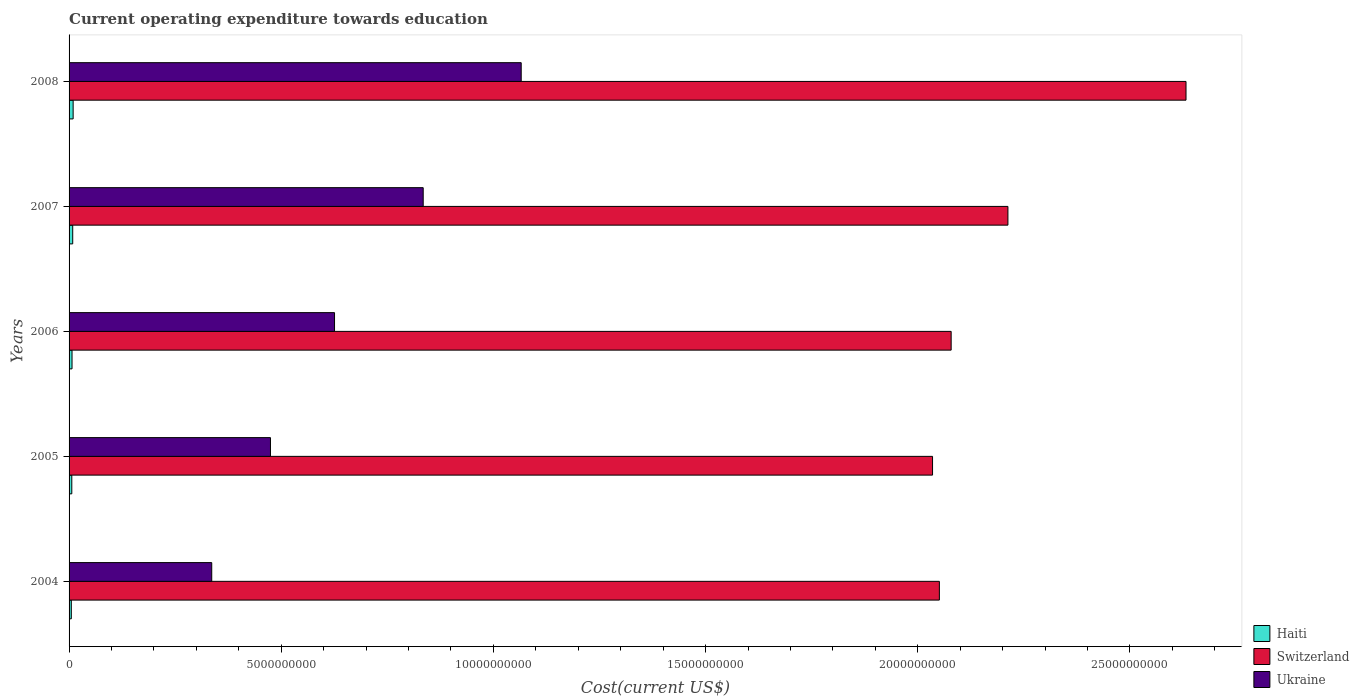How many different coloured bars are there?
Give a very brief answer. 3. How many groups of bars are there?
Ensure brevity in your answer.  5. Are the number of bars per tick equal to the number of legend labels?
Offer a terse response. Yes. How many bars are there on the 3rd tick from the top?
Your answer should be compact. 3. What is the label of the 4th group of bars from the top?
Offer a very short reply. 2005. In how many cases, is the number of bars for a given year not equal to the number of legend labels?
Offer a very short reply. 0. What is the expenditure towards education in Haiti in 2006?
Provide a succinct answer. 6.96e+07. Across all years, what is the maximum expenditure towards education in Ukraine?
Provide a short and direct response. 1.07e+1. Across all years, what is the minimum expenditure towards education in Switzerland?
Make the answer very short. 2.03e+1. In which year was the expenditure towards education in Ukraine maximum?
Your response must be concise. 2008. What is the total expenditure towards education in Ukraine in the graph?
Provide a succinct answer. 3.34e+1. What is the difference between the expenditure towards education in Haiti in 2004 and that in 2007?
Provide a succinct answer. -3.33e+07. What is the difference between the expenditure towards education in Switzerland in 2006 and the expenditure towards education in Haiti in 2008?
Your answer should be compact. 2.07e+1. What is the average expenditure towards education in Ukraine per year?
Provide a short and direct response. 6.67e+09. In the year 2006, what is the difference between the expenditure towards education in Switzerland and expenditure towards education in Ukraine?
Provide a succinct answer. 1.45e+1. What is the ratio of the expenditure towards education in Switzerland in 2005 to that in 2008?
Your answer should be very brief. 0.77. Is the expenditure towards education in Haiti in 2005 less than that in 2006?
Give a very brief answer. Yes. Is the difference between the expenditure towards education in Switzerland in 2006 and 2007 greater than the difference between the expenditure towards education in Ukraine in 2006 and 2007?
Your answer should be compact. Yes. What is the difference between the highest and the second highest expenditure towards education in Switzerland?
Ensure brevity in your answer.  4.20e+09. What is the difference between the highest and the lowest expenditure towards education in Ukraine?
Offer a very short reply. 7.29e+09. Is the sum of the expenditure towards education in Switzerland in 2005 and 2008 greater than the maximum expenditure towards education in Ukraine across all years?
Ensure brevity in your answer.  Yes. What does the 1st bar from the top in 2006 represents?
Provide a short and direct response. Ukraine. What does the 2nd bar from the bottom in 2005 represents?
Your answer should be very brief. Switzerland. How many bars are there?
Provide a short and direct response. 15. How many years are there in the graph?
Your response must be concise. 5. Are the values on the major ticks of X-axis written in scientific E-notation?
Give a very brief answer. No. Does the graph contain any zero values?
Your answer should be compact. No. Does the graph contain grids?
Provide a succinct answer. No. What is the title of the graph?
Ensure brevity in your answer.  Current operating expenditure towards education. What is the label or title of the X-axis?
Offer a very short reply. Cost(current US$). What is the label or title of the Y-axis?
Your response must be concise. Years. What is the Cost(current US$) of Haiti in 2004?
Ensure brevity in your answer.  5.28e+07. What is the Cost(current US$) in Switzerland in 2004?
Offer a terse response. 2.05e+1. What is the Cost(current US$) of Ukraine in 2004?
Your answer should be compact. 3.36e+09. What is the Cost(current US$) in Haiti in 2005?
Keep it short and to the point. 6.41e+07. What is the Cost(current US$) of Switzerland in 2005?
Keep it short and to the point. 2.03e+1. What is the Cost(current US$) in Ukraine in 2005?
Your answer should be very brief. 4.75e+09. What is the Cost(current US$) in Haiti in 2006?
Provide a succinct answer. 6.96e+07. What is the Cost(current US$) of Switzerland in 2006?
Provide a succinct answer. 2.08e+1. What is the Cost(current US$) of Ukraine in 2006?
Your answer should be compact. 6.26e+09. What is the Cost(current US$) of Haiti in 2007?
Offer a very short reply. 8.61e+07. What is the Cost(current US$) in Switzerland in 2007?
Offer a very short reply. 2.21e+1. What is the Cost(current US$) of Ukraine in 2007?
Provide a short and direct response. 8.35e+09. What is the Cost(current US$) of Haiti in 2008?
Your answer should be very brief. 9.58e+07. What is the Cost(current US$) of Switzerland in 2008?
Offer a terse response. 2.63e+1. What is the Cost(current US$) of Ukraine in 2008?
Offer a very short reply. 1.07e+1. Across all years, what is the maximum Cost(current US$) in Haiti?
Keep it short and to the point. 9.58e+07. Across all years, what is the maximum Cost(current US$) in Switzerland?
Your answer should be very brief. 2.63e+1. Across all years, what is the maximum Cost(current US$) in Ukraine?
Make the answer very short. 1.07e+1. Across all years, what is the minimum Cost(current US$) in Haiti?
Keep it short and to the point. 5.28e+07. Across all years, what is the minimum Cost(current US$) of Switzerland?
Provide a short and direct response. 2.03e+1. Across all years, what is the minimum Cost(current US$) of Ukraine?
Make the answer very short. 3.36e+09. What is the total Cost(current US$) in Haiti in the graph?
Ensure brevity in your answer.  3.68e+08. What is the total Cost(current US$) in Switzerland in the graph?
Offer a very short reply. 1.10e+11. What is the total Cost(current US$) in Ukraine in the graph?
Ensure brevity in your answer.  3.34e+1. What is the difference between the Cost(current US$) in Haiti in 2004 and that in 2005?
Ensure brevity in your answer.  -1.13e+07. What is the difference between the Cost(current US$) in Switzerland in 2004 and that in 2005?
Give a very brief answer. 1.61e+08. What is the difference between the Cost(current US$) of Ukraine in 2004 and that in 2005?
Provide a short and direct response. -1.38e+09. What is the difference between the Cost(current US$) of Haiti in 2004 and that in 2006?
Give a very brief answer. -1.68e+07. What is the difference between the Cost(current US$) of Switzerland in 2004 and that in 2006?
Offer a very short reply. -2.77e+08. What is the difference between the Cost(current US$) in Ukraine in 2004 and that in 2006?
Your answer should be compact. -2.89e+09. What is the difference between the Cost(current US$) of Haiti in 2004 and that in 2007?
Give a very brief answer. -3.33e+07. What is the difference between the Cost(current US$) in Switzerland in 2004 and that in 2007?
Your response must be concise. -1.62e+09. What is the difference between the Cost(current US$) in Ukraine in 2004 and that in 2007?
Offer a very short reply. -4.98e+09. What is the difference between the Cost(current US$) in Haiti in 2004 and that in 2008?
Provide a short and direct response. -4.30e+07. What is the difference between the Cost(current US$) of Switzerland in 2004 and that in 2008?
Provide a succinct answer. -5.81e+09. What is the difference between the Cost(current US$) of Ukraine in 2004 and that in 2008?
Provide a short and direct response. -7.29e+09. What is the difference between the Cost(current US$) of Haiti in 2005 and that in 2006?
Your answer should be very brief. -5.51e+06. What is the difference between the Cost(current US$) in Switzerland in 2005 and that in 2006?
Provide a short and direct response. -4.38e+08. What is the difference between the Cost(current US$) of Ukraine in 2005 and that in 2006?
Make the answer very short. -1.51e+09. What is the difference between the Cost(current US$) of Haiti in 2005 and that in 2007?
Make the answer very short. -2.19e+07. What is the difference between the Cost(current US$) in Switzerland in 2005 and that in 2007?
Provide a short and direct response. -1.78e+09. What is the difference between the Cost(current US$) in Ukraine in 2005 and that in 2007?
Offer a very short reply. -3.60e+09. What is the difference between the Cost(current US$) in Haiti in 2005 and that in 2008?
Provide a succinct answer. -3.17e+07. What is the difference between the Cost(current US$) of Switzerland in 2005 and that in 2008?
Provide a succinct answer. -5.97e+09. What is the difference between the Cost(current US$) in Ukraine in 2005 and that in 2008?
Give a very brief answer. -5.91e+09. What is the difference between the Cost(current US$) of Haiti in 2006 and that in 2007?
Offer a very short reply. -1.64e+07. What is the difference between the Cost(current US$) in Switzerland in 2006 and that in 2007?
Your response must be concise. -1.34e+09. What is the difference between the Cost(current US$) of Ukraine in 2006 and that in 2007?
Provide a succinct answer. -2.09e+09. What is the difference between the Cost(current US$) of Haiti in 2006 and that in 2008?
Provide a short and direct response. -2.62e+07. What is the difference between the Cost(current US$) of Switzerland in 2006 and that in 2008?
Keep it short and to the point. -5.53e+09. What is the difference between the Cost(current US$) of Ukraine in 2006 and that in 2008?
Give a very brief answer. -4.40e+09. What is the difference between the Cost(current US$) in Haiti in 2007 and that in 2008?
Provide a short and direct response. -9.74e+06. What is the difference between the Cost(current US$) in Switzerland in 2007 and that in 2008?
Keep it short and to the point. -4.20e+09. What is the difference between the Cost(current US$) of Ukraine in 2007 and that in 2008?
Give a very brief answer. -2.31e+09. What is the difference between the Cost(current US$) of Haiti in 2004 and the Cost(current US$) of Switzerland in 2005?
Your answer should be compact. -2.03e+1. What is the difference between the Cost(current US$) in Haiti in 2004 and the Cost(current US$) in Ukraine in 2005?
Offer a very short reply. -4.69e+09. What is the difference between the Cost(current US$) in Switzerland in 2004 and the Cost(current US$) in Ukraine in 2005?
Offer a terse response. 1.58e+1. What is the difference between the Cost(current US$) in Haiti in 2004 and the Cost(current US$) in Switzerland in 2006?
Make the answer very short. -2.07e+1. What is the difference between the Cost(current US$) in Haiti in 2004 and the Cost(current US$) in Ukraine in 2006?
Ensure brevity in your answer.  -6.20e+09. What is the difference between the Cost(current US$) of Switzerland in 2004 and the Cost(current US$) of Ukraine in 2006?
Keep it short and to the point. 1.43e+1. What is the difference between the Cost(current US$) in Haiti in 2004 and the Cost(current US$) in Switzerland in 2007?
Ensure brevity in your answer.  -2.21e+1. What is the difference between the Cost(current US$) in Haiti in 2004 and the Cost(current US$) in Ukraine in 2007?
Your answer should be very brief. -8.29e+09. What is the difference between the Cost(current US$) of Switzerland in 2004 and the Cost(current US$) of Ukraine in 2007?
Keep it short and to the point. 1.22e+1. What is the difference between the Cost(current US$) in Haiti in 2004 and the Cost(current US$) in Switzerland in 2008?
Offer a very short reply. -2.63e+1. What is the difference between the Cost(current US$) of Haiti in 2004 and the Cost(current US$) of Ukraine in 2008?
Ensure brevity in your answer.  -1.06e+1. What is the difference between the Cost(current US$) in Switzerland in 2004 and the Cost(current US$) in Ukraine in 2008?
Provide a succinct answer. 9.85e+09. What is the difference between the Cost(current US$) in Haiti in 2005 and the Cost(current US$) in Switzerland in 2006?
Offer a terse response. -2.07e+1. What is the difference between the Cost(current US$) of Haiti in 2005 and the Cost(current US$) of Ukraine in 2006?
Provide a succinct answer. -6.19e+09. What is the difference between the Cost(current US$) of Switzerland in 2005 and the Cost(current US$) of Ukraine in 2006?
Offer a terse response. 1.41e+1. What is the difference between the Cost(current US$) in Haiti in 2005 and the Cost(current US$) in Switzerland in 2007?
Your response must be concise. -2.21e+1. What is the difference between the Cost(current US$) in Haiti in 2005 and the Cost(current US$) in Ukraine in 2007?
Offer a terse response. -8.28e+09. What is the difference between the Cost(current US$) of Switzerland in 2005 and the Cost(current US$) of Ukraine in 2007?
Offer a very short reply. 1.20e+1. What is the difference between the Cost(current US$) in Haiti in 2005 and the Cost(current US$) in Switzerland in 2008?
Offer a very short reply. -2.63e+1. What is the difference between the Cost(current US$) in Haiti in 2005 and the Cost(current US$) in Ukraine in 2008?
Provide a short and direct response. -1.06e+1. What is the difference between the Cost(current US$) of Switzerland in 2005 and the Cost(current US$) of Ukraine in 2008?
Your response must be concise. 9.69e+09. What is the difference between the Cost(current US$) of Haiti in 2006 and the Cost(current US$) of Switzerland in 2007?
Make the answer very short. -2.21e+1. What is the difference between the Cost(current US$) of Haiti in 2006 and the Cost(current US$) of Ukraine in 2007?
Your answer should be very brief. -8.28e+09. What is the difference between the Cost(current US$) of Switzerland in 2006 and the Cost(current US$) of Ukraine in 2007?
Your answer should be compact. 1.24e+1. What is the difference between the Cost(current US$) in Haiti in 2006 and the Cost(current US$) in Switzerland in 2008?
Ensure brevity in your answer.  -2.63e+1. What is the difference between the Cost(current US$) of Haiti in 2006 and the Cost(current US$) of Ukraine in 2008?
Provide a succinct answer. -1.06e+1. What is the difference between the Cost(current US$) of Switzerland in 2006 and the Cost(current US$) of Ukraine in 2008?
Give a very brief answer. 1.01e+1. What is the difference between the Cost(current US$) of Haiti in 2007 and the Cost(current US$) of Switzerland in 2008?
Your answer should be very brief. -2.62e+1. What is the difference between the Cost(current US$) of Haiti in 2007 and the Cost(current US$) of Ukraine in 2008?
Keep it short and to the point. -1.06e+1. What is the difference between the Cost(current US$) of Switzerland in 2007 and the Cost(current US$) of Ukraine in 2008?
Offer a terse response. 1.15e+1. What is the average Cost(current US$) of Haiti per year?
Your answer should be very brief. 7.37e+07. What is the average Cost(current US$) of Switzerland per year?
Offer a terse response. 2.20e+1. What is the average Cost(current US$) of Ukraine per year?
Offer a very short reply. 6.67e+09. In the year 2004, what is the difference between the Cost(current US$) of Haiti and Cost(current US$) of Switzerland?
Make the answer very short. -2.05e+1. In the year 2004, what is the difference between the Cost(current US$) of Haiti and Cost(current US$) of Ukraine?
Your answer should be very brief. -3.31e+09. In the year 2004, what is the difference between the Cost(current US$) in Switzerland and Cost(current US$) in Ukraine?
Your answer should be very brief. 1.71e+1. In the year 2005, what is the difference between the Cost(current US$) of Haiti and Cost(current US$) of Switzerland?
Offer a terse response. -2.03e+1. In the year 2005, what is the difference between the Cost(current US$) in Haiti and Cost(current US$) in Ukraine?
Your response must be concise. -4.68e+09. In the year 2005, what is the difference between the Cost(current US$) of Switzerland and Cost(current US$) of Ukraine?
Your response must be concise. 1.56e+1. In the year 2006, what is the difference between the Cost(current US$) of Haiti and Cost(current US$) of Switzerland?
Offer a very short reply. -2.07e+1. In the year 2006, what is the difference between the Cost(current US$) in Haiti and Cost(current US$) in Ukraine?
Ensure brevity in your answer.  -6.19e+09. In the year 2006, what is the difference between the Cost(current US$) of Switzerland and Cost(current US$) of Ukraine?
Your response must be concise. 1.45e+1. In the year 2007, what is the difference between the Cost(current US$) of Haiti and Cost(current US$) of Switzerland?
Provide a short and direct response. -2.20e+1. In the year 2007, what is the difference between the Cost(current US$) of Haiti and Cost(current US$) of Ukraine?
Give a very brief answer. -8.26e+09. In the year 2007, what is the difference between the Cost(current US$) of Switzerland and Cost(current US$) of Ukraine?
Provide a short and direct response. 1.38e+1. In the year 2008, what is the difference between the Cost(current US$) in Haiti and Cost(current US$) in Switzerland?
Offer a very short reply. -2.62e+1. In the year 2008, what is the difference between the Cost(current US$) in Haiti and Cost(current US$) in Ukraine?
Your answer should be compact. -1.06e+1. In the year 2008, what is the difference between the Cost(current US$) in Switzerland and Cost(current US$) in Ukraine?
Offer a very short reply. 1.57e+1. What is the ratio of the Cost(current US$) in Haiti in 2004 to that in 2005?
Your response must be concise. 0.82. What is the ratio of the Cost(current US$) of Switzerland in 2004 to that in 2005?
Your answer should be compact. 1.01. What is the ratio of the Cost(current US$) of Ukraine in 2004 to that in 2005?
Offer a terse response. 0.71. What is the ratio of the Cost(current US$) of Haiti in 2004 to that in 2006?
Give a very brief answer. 0.76. What is the ratio of the Cost(current US$) in Switzerland in 2004 to that in 2006?
Provide a short and direct response. 0.99. What is the ratio of the Cost(current US$) in Ukraine in 2004 to that in 2006?
Provide a succinct answer. 0.54. What is the ratio of the Cost(current US$) of Haiti in 2004 to that in 2007?
Provide a succinct answer. 0.61. What is the ratio of the Cost(current US$) of Switzerland in 2004 to that in 2007?
Your response must be concise. 0.93. What is the ratio of the Cost(current US$) of Ukraine in 2004 to that in 2007?
Provide a succinct answer. 0.4. What is the ratio of the Cost(current US$) of Haiti in 2004 to that in 2008?
Provide a short and direct response. 0.55. What is the ratio of the Cost(current US$) of Switzerland in 2004 to that in 2008?
Offer a terse response. 0.78. What is the ratio of the Cost(current US$) in Ukraine in 2004 to that in 2008?
Give a very brief answer. 0.32. What is the ratio of the Cost(current US$) of Haiti in 2005 to that in 2006?
Provide a short and direct response. 0.92. What is the ratio of the Cost(current US$) of Switzerland in 2005 to that in 2006?
Give a very brief answer. 0.98. What is the ratio of the Cost(current US$) of Ukraine in 2005 to that in 2006?
Keep it short and to the point. 0.76. What is the ratio of the Cost(current US$) of Haiti in 2005 to that in 2007?
Your answer should be very brief. 0.75. What is the ratio of the Cost(current US$) in Switzerland in 2005 to that in 2007?
Offer a terse response. 0.92. What is the ratio of the Cost(current US$) of Ukraine in 2005 to that in 2007?
Provide a succinct answer. 0.57. What is the ratio of the Cost(current US$) in Haiti in 2005 to that in 2008?
Give a very brief answer. 0.67. What is the ratio of the Cost(current US$) in Switzerland in 2005 to that in 2008?
Provide a short and direct response. 0.77. What is the ratio of the Cost(current US$) in Ukraine in 2005 to that in 2008?
Your response must be concise. 0.45. What is the ratio of the Cost(current US$) in Haiti in 2006 to that in 2007?
Your answer should be compact. 0.81. What is the ratio of the Cost(current US$) of Switzerland in 2006 to that in 2007?
Provide a succinct answer. 0.94. What is the ratio of the Cost(current US$) of Ukraine in 2006 to that in 2007?
Make the answer very short. 0.75. What is the ratio of the Cost(current US$) of Haiti in 2006 to that in 2008?
Your response must be concise. 0.73. What is the ratio of the Cost(current US$) in Switzerland in 2006 to that in 2008?
Your answer should be compact. 0.79. What is the ratio of the Cost(current US$) in Ukraine in 2006 to that in 2008?
Offer a very short reply. 0.59. What is the ratio of the Cost(current US$) in Haiti in 2007 to that in 2008?
Offer a very short reply. 0.9. What is the ratio of the Cost(current US$) in Switzerland in 2007 to that in 2008?
Ensure brevity in your answer.  0.84. What is the ratio of the Cost(current US$) in Ukraine in 2007 to that in 2008?
Offer a terse response. 0.78. What is the difference between the highest and the second highest Cost(current US$) in Haiti?
Keep it short and to the point. 9.74e+06. What is the difference between the highest and the second highest Cost(current US$) in Switzerland?
Give a very brief answer. 4.20e+09. What is the difference between the highest and the second highest Cost(current US$) in Ukraine?
Your answer should be compact. 2.31e+09. What is the difference between the highest and the lowest Cost(current US$) of Haiti?
Ensure brevity in your answer.  4.30e+07. What is the difference between the highest and the lowest Cost(current US$) in Switzerland?
Make the answer very short. 5.97e+09. What is the difference between the highest and the lowest Cost(current US$) of Ukraine?
Make the answer very short. 7.29e+09. 